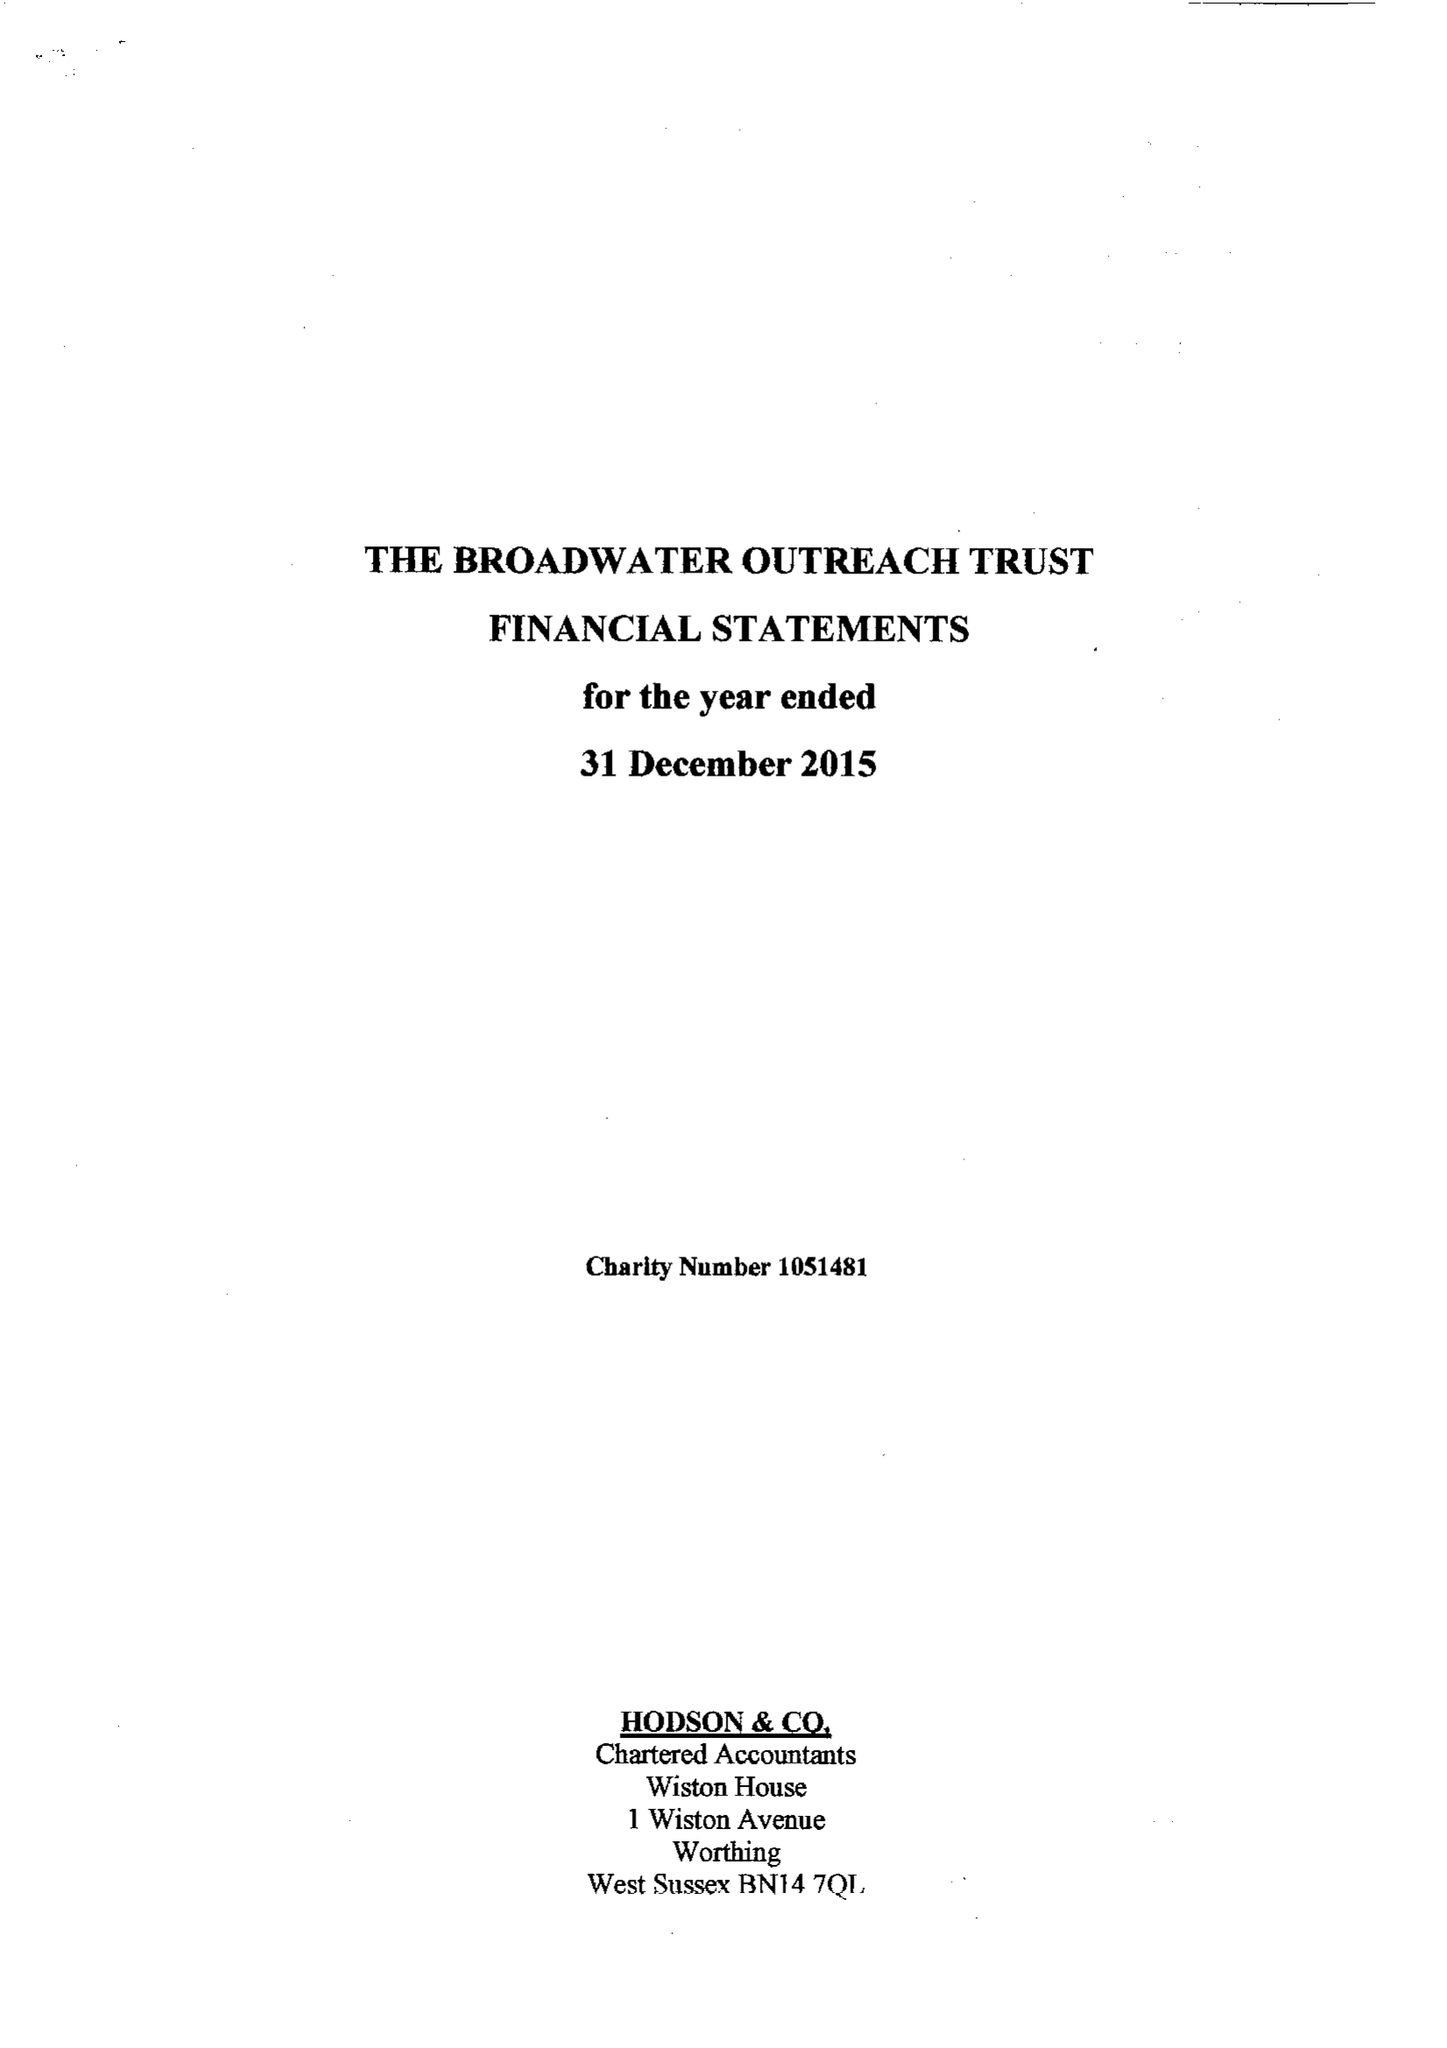What is the value for the address__street_line?
Answer the question using a single word or phrase. 117 BROADWATER ROAD 